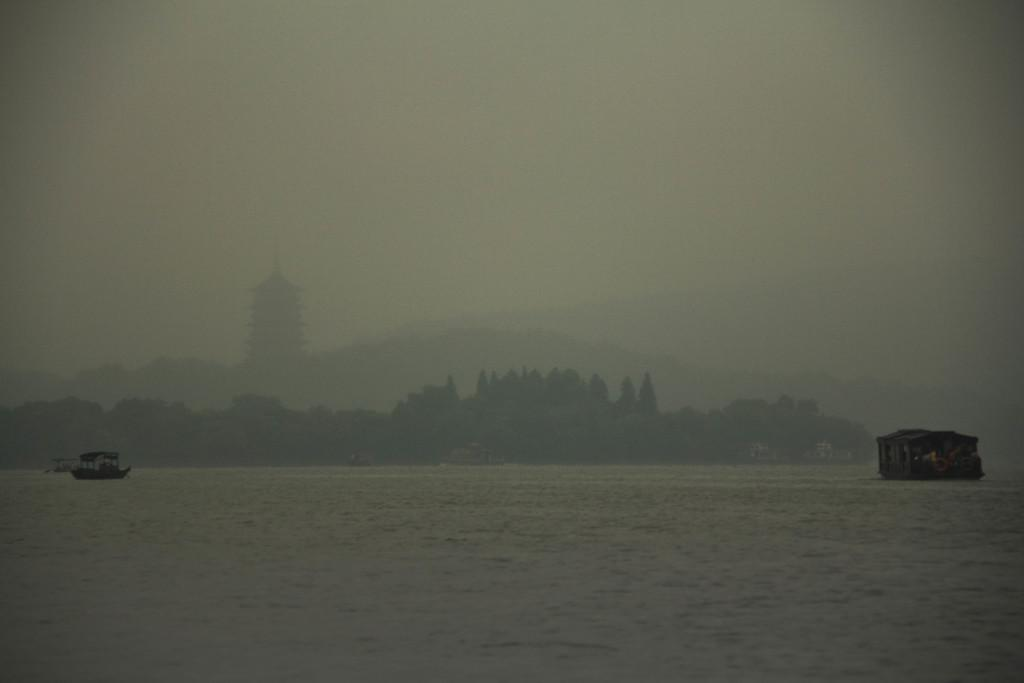What type of vehicles can be seen in the water in the image? There are boats in the water in the image. What is the primary element in which the boats are situated? The boats are situated in water. What can be seen in the background of the image? There are trees, a building, and the sky visible in the background of the image. What type of engine is powering the boats in the image? The image does not provide information about the engines powering the boats, so it cannot be determined from the image. 